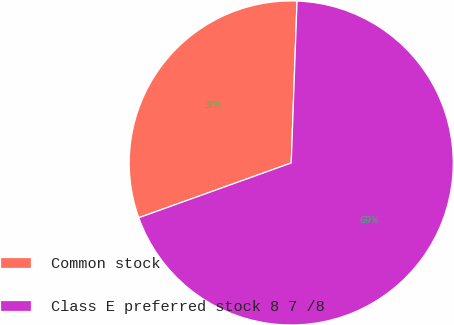Convert chart. <chart><loc_0><loc_0><loc_500><loc_500><pie_chart><fcel>Common stock<fcel>Class E preferred stock 8 7 /8<nl><fcel>31.06%<fcel>68.94%<nl></chart> 